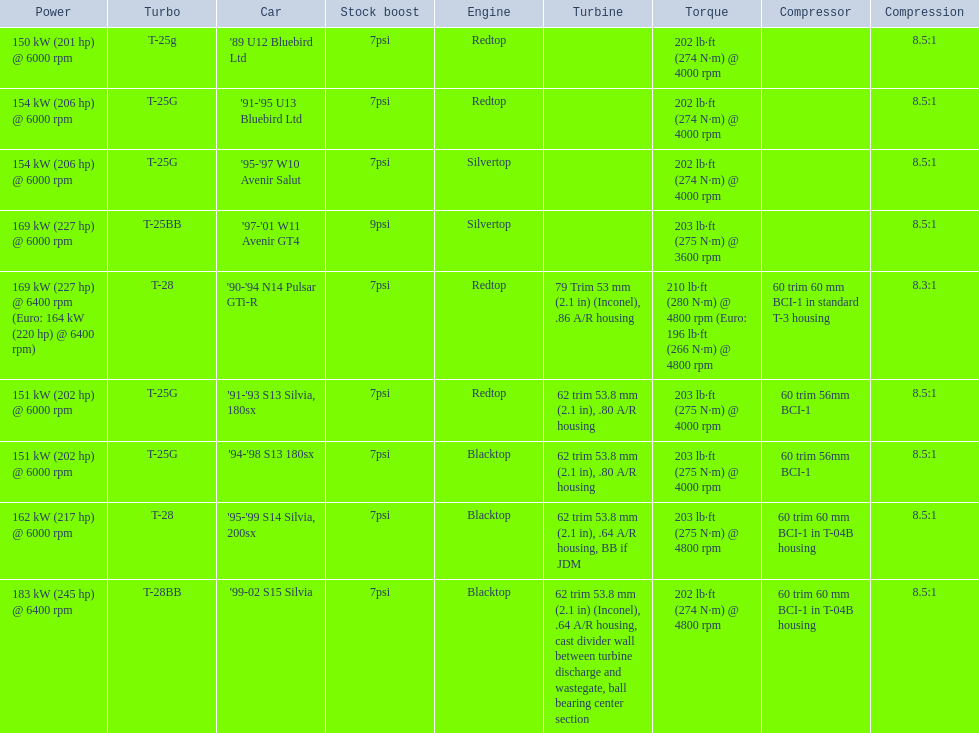What are the listed hp of the cars? 150 kW (201 hp) @ 6000 rpm, 154 kW (206 hp) @ 6000 rpm, 154 kW (206 hp) @ 6000 rpm, 169 kW (227 hp) @ 6000 rpm, 169 kW (227 hp) @ 6400 rpm (Euro: 164 kW (220 hp) @ 6400 rpm), 151 kW (202 hp) @ 6000 rpm, 151 kW (202 hp) @ 6000 rpm, 162 kW (217 hp) @ 6000 rpm, 183 kW (245 hp) @ 6400 rpm. Which is the only car with over 230 hp? '99-02 S15 Silvia. 